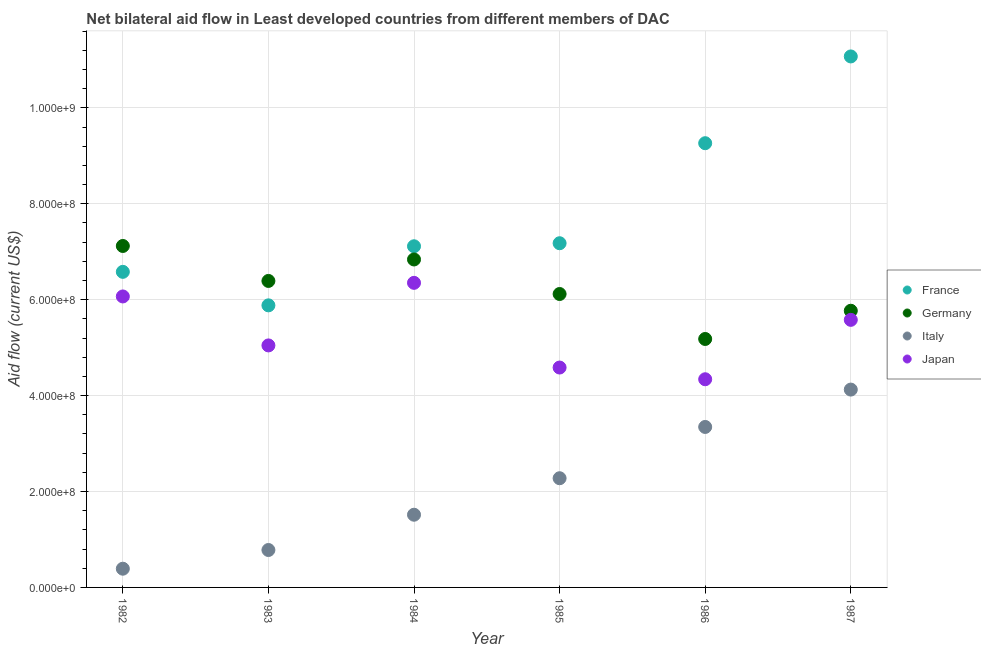What is the amount of aid given by italy in 1983?
Your response must be concise. 7.80e+07. Across all years, what is the maximum amount of aid given by japan?
Offer a very short reply. 6.35e+08. Across all years, what is the minimum amount of aid given by france?
Offer a very short reply. 5.88e+08. In which year was the amount of aid given by france minimum?
Provide a succinct answer. 1983. What is the total amount of aid given by germany in the graph?
Your response must be concise. 3.74e+09. What is the difference between the amount of aid given by germany in 1984 and that in 1985?
Make the answer very short. 7.20e+07. What is the difference between the amount of aid given by france in 1985 and the amount of aid given by italy in 1984?
Your answer should be compact. 5.66e+08. What is the average amount of aid given by france per year?
Ensure brevity in your answer.  7.85e+08. In the year 1982, what is the difference between the amount of aid given by japan and amount of aid given by germany?
Give a very brief answer. -1.05e+08. In how many years, is the amount of aid given by france greater than 1080000000 US$?
Provide a succinct answer. 1. What is the ratio of the amount of aid given by france in 1984 to that in 1985?
Keep it short and to the point. 0.99. Is the amount of aid given by japan in 1982 less than that in 1983?
Make the answer very short. No. What is the difference between the highest and the second highest amount of aid given by italy?
Provide a short and direct response. 7.79e+07. What is the difference between the highest and the lowest amount of aid given by japan?
Provide a succinct answer. 2.01e+08. Is the sum of the amount of aid given by germany in 1986 and 1987 greater than the maximum amount of aid given by italy across all years?
Provide a succinct answer. Yes. Is the amount of aid given by france strictly greater than the amount of aid given by germany over the years?
Offer a very short reply. No. How many dotlines are there?
Offer a very short reply. 4. How many years are there in the graph?
Your answer should be very brief. 6. What is the difference between two consecutive major ticks on the Y-axis?
Provide a short and direct response. 2.00e+08. Are the values on the major ticks of Y-axis written in scientific E-notation?
Provide a short and direct response. Yes. Does the graph contain any zero values?
Offer a very short reply. No. Does the graph contain grids?
Your answer should be compact. Yes. How many legend labels are there?
Your answer should be compact. 4. What is the title of the graph?
Make the answer very short. Net bilateral aid flow in Least developed countries from different members of DAC. Does "WFP" appear as one of the legend labels in the graph?
Offer a very short reply. No. What is the label or title of the Y-axis?
Your answer should be very brief. Aid flow (current US$). What is the Aid flow (current US$) in France in 1982?
Make the answer very short. 6.58e+08. What is the Aid flow (current US$) of Germany in 1982?
Provide a short and direct response. 7.12e+08. What is the Aid flow (current US$) in Italy in 1982?
Your answer should be compact. 3.90e+07. What is the Aid flow (current US$) in Japan in 1982?
Keep it short and to the point. 6.07e+08. What is the Aid flow (current US$) of France in 1983?
Your answer should be very brief. 5.88e+08. What is the Aid flow (current US$) in Germany in 1983?
Your answer should be compact. 6.39e+08. What is the Aid flow (current US$) of Italy in 1983?
Provide a succinct answer. 7.80e+07. What is the Aid flow (current US$) in Japan in 1983?
Provide a short and direct response. 5.05e+08. What is the Aid flow (current US$) of France in 1984?
Your answer should be very brief. 7.11e+08. What is the Aid flow (current US$) of Germany in 1984?
Offer a terse response. 6.84e+08. What is the Aid flow (current US$) of Italy in 1984?
Your answer should be very brief. 1.52e+08. What is the Aid flow (current US$) in Japan in 1984?
Your answer should be compact. 6.35e+08. What is the Aid flow (current US$) of France in 1985?
Offer a very short reply. 7.18e+08. What is the Aid flow (current US$) of Germany in 1985?
Give a very brief answer. 6.12e+08. What is the Aid flow (current US$) in Italy in 1985?
Give a very brief answer. 2.28e+08. What is the Aid flow (current US$) of Japan in 1985?
Keep it short and to the point. 4.58e+08. What is the Aid flow (current US$) in France in 1986?
Make the answer very short. 9.26e+08. What is the Aid flow (current US$) in Germany in 1986?
Make the answer very short. 5.18e+08. What is the Aid flow (current US$) of Italy in 1986?
Give a very brief answer. 3.35e+08. What is the Aid flow (current US$) in Japan in 1986?
Your response must be concise. 4.34e+08. What is the Aid flow (current US$) in France in 1987?
Your response must be concise. 1.11e+09. What is the Aid flow (current US$) in Germany in 1987?
Make the answer very short. 5.77e+08. What is the Aid flow (current US$) in Italy in 1987?
Make the answer very short. 4.13e+08. What is the Aid flow (current US$) of Japan in 1987?
Provide a succinct answer. 5.58e+08. Across all years, what is the maximum Aid flow (current US$) of France?
Your response must be concise. 1.11e+09. Across all years, what is the maximum Aid flow (current US$) of Germany?
Your response must be concise. 7.12e+08. Across all years, what is the maximum Aid flow (current US$) of Italy?
Keep it short and to the point. 4.13e+08. Across all years, what is the maximum Aid flow (current US$) of Japan?
Provide a short and direct response. 6.35e+08. Across all years, what is the minimum Aid flow (current US$) in France?
Offer a very short reply. 5.88e+08. Across all years, what is the minimum Aid flow (current US$) in Germany?
Your response must be concise. 5.18e+08. Across all years, what is the minimum Aid flow (current US$) in Italy?
Your response must be concise. 3.90e+07. Across all years, what is the minimum Aid flow (current US$) in Japan?
Your answer should be very brief. 4.34e+08. What is the total Aid flow (current US$) of France in the graph?
Offer a terse response. 4.71e+09. What is the total Aid flow (current US$) in Germany in the graph?
Your answer should be compact. 3.74e+09. What is the total Aid flow (current US$) of Italy in the graph?
Give a very brief answer. 1.24e+09. What is the total Aid flow (current US$) in Japan in the graph?
Keep it short and to the point. 3.20e+09. What is the difference between the Aid flow (current US$) in France in 1982 and that in 1983?
Ensure brevity in your answer.  6.98e+07. What is the difference between the Aid flow (current US$) of Germany in 1982 and that in 1983?
Make the answer very short. 7.29e+07. What is the difference between the Aid flow (current US$) of Italy in 1982 and that in 1983?
Your response must be concise. -3.90e+07. What is the difference between the Aid flow (current US$) in Japan in 1982 and that in 1983?
Make the answer very short. 1.02e+08. What is the difference between the Aid flow (current US$) of France in 1982 and that in 1984?
Provide a short and direct response. -5.33e+07. What is the difference between the Aid flow (current US$) in Germany in 1982 and that in 1984?
Ensure brevity in your answer.  2.81e+07. What is the difference between the Aid flow (current US$) in Italy in 1982 and that in 1984?
Keep it short and to the point. -1.13e+08. What is the difference between the Aid flow (current US$) of Japan in 1982 and that in 1984?
Provide a succinct answer. -2.84e+07. What is the difference between the Aid flow (current US$) of France in 1982 and that in 1985?
Offer a very short reply. -5.97e+07. What is the difference between the Aid flow (current US$) in Germany in 1982 and that in 1985?
Keep it short and to the point. 1.00e+08. What is the difference between the Aid flow (current US$) of Italy in 1982 and that in 1985?
Your answer should be compact. -1.89e+08. What is the difference between the Aid flow (current US$) in Japan in 1982 and that in 1985?
Ensure brevity in your answer.  1.48e+08. What is the difference between the Aid flow (current US$) of France in 1982 and that in 1986?
Provide a short and direct response. -2.68e+08. What is the difference between the Aid flow (current US$) of Germany in 1982 and that in 1986?
Your answer should be very brief. 1.94e+08. What is the difference between the Aid flow (current US$) of Italy in 1982 and that in 1986?
Offer a very short reply. -2.96e+08. What is the difference between the Aid flow (current US$) of Japan in 1982 and that in 1986?
Provide a short and direct response. 1.73e+08. What is the difference between the Aid flow (current US$) in France in 1982 and that in 1987?
Provide a short and direct response. -4.49e+08. What is the difference between the Aid flow (current US$) in Germany in 1982 and that in 1987?
Provide a short and direct response. 1.35e+08. What is the difference between the Aid flow (current US$) in Italy in 1982 and that in 1987?
Your answer should be very brief. -3.74e+08. What is the difference between the Aid flow (current US$) of Japan in 1982 and that in 1987?
Make the answer very short. 4.88e+07. What is the difference between the Aid flow (current US$) of France in 1983 and that in 1984?
Provide a short and direct response. -1.23e+08. What is the difference between the Aid flow (current US$) in Germany in 1983 and that in 1984?
Keep it short and to the point. -4.48e+07. What is the difference between the Aid flow (current US$) of Italy in 1983 and that in 1984?
Offer a terse response. -7.36e+07. What is the difference between the Aid flow (current US$) in Japan in 1983 and that in 1984?
Provide a succinct answer. -1.30e+08. What is the difference between the Aid flow (current US$) of France in 1983 and that in 1985?
Make the answer very short. -1.30e+08. What is the difference between the Aid flow (current US$) of Germany in 1983 and that in 1985?
Your answer should be very brief. 2.72e+07. What is the difference between the Aid flow (current US$) of Italy in 1983 and that in 1985?
Provide a succinct answer. -1.50e+08. What is the difference between the Aid flow (current US$) in Japan in 1983 and that in 1985?
Make the answer very short. 4.61e+07. What is the difference between the Aid flow (current US$) of France in 1983 and that in 1986?
Give a very brief answer. -3.38e+08. What is the difference between the Aid flow (current US$) of Germany in 1983 and that in 1986?
Your answer should be very brief. 1.21e+08. What is the difference between the Aid flow (current US$) in Italy in 1983 and that in 1986?
Give a very brief answer. -2.57e+08. What is the difference between the Aid flow (current US$) of Japan in 1983 and that in 1986?
Offer a terse response. 7.06e+07. What is the difference between the Aid flow (current US$) of France in 1983 and that in 1987?
Your response must be concise. -5.19e+08. What is the difference between the Aid flow (current US$) in Germany in 1983 and that in 1987?
Make the answer very short. 6.22e+07. What is the difference between the Aid flow (current US$) in Italy in 1983 and that in 1987?
Your answer should be very brief. -3.35e+08. What is the difference between the Aid flow (current US$) in Japan in 1983 and that in 1987?
Make the answer very short. -5.33e+07. What is the difference between the Aid flow (current US$) in France in 1984 and that in 1985?
Make the answer very short. -6.33e+06. What is the difference between the Aid flow (current US$) in Germany in 1984 and that in 1985?
Offer a terse response. 7.20e+07. What is the difference between the Aid flow (current US$) in Italy in 1984 and that in 1985?
Offer a terse response. -7.61e+07. What is the difference between the Aid flow (current US$) of Japan in 1984 and that in 1985?
Ensure brevity in your answer.  1.77e+08. What is the difference between the Aid flow (current US$) of France in 1984 and that in 1986?
Keep it short and to the point. -2.15e+08. What is the difference between the Aid flow (current US$) of Germany in 1984 and that in 1986?
Your response must be concise. 1.66e+08. What is the difference between the Aid flow (current US$) in Italy in 1984 and that in 1986?
Offer a very short reply. -1.83e+08. What is the difference between the Aid flow (current US$) of Japan in 1984 and that in 1986?
Ensure brevity in your answer.  2.01e+08. What is the difference between the Aid flow (current US$) of France in 1984 and that in 1987?
Provide a succinct answer. -3.96e+08. What is the difference between the Aid flow (current US$) of Germany in 1984 and that in 1987?
Make the answer very short. 1.07e+08. What is the difference between the Aid flow (current US$) of Italy in 1984 and that in 1987?
Your answer should be very brief. -2.61e+08. What is the difference between the Aid flow (current US$) in Japan in 1984 and that in 1987?
Make the answer very short. 7.72e+07. What is the difference between the Aid flow (current US$) in France in 1985 and that in 1986?
Offer a terse response. -2.09e+08. What is the difference between the Aid flow (current US$) in Germany in 1985 and that in 1986?
Provide a short and direct response. 9.38e+07. What is the difference between the Aid flow (current US$) in Italy in 1985 and that in 1986?
Provide a short and direct response. -1.07e+08. What is the difference between the Aid flow (current US$) in Japan in 1985 and that in 1986?
Give a very brief answer. 2.44e+07. What is the difference between the Aid flow (current US$) of France in 1985 and that in 1987?
Ensure brevity in your answer.  -3.89e+08. What is the difference between the Aid flow (current US$) of Germany in 1985 and that in 1987?
Give a very brief answer. 3.49e+07. What is the difference between the Aid flow (current US$) in Italy in 1985 and that in 1987?
Your answer should be compact. -1.85e+08. What is the difference between the Aid flow (current US$) in Japan in 1985 and that in 1987?
Offer a terse response. -9.94e+07. What is the difference between the Aid flow (current US$) in France in 1986 and that in 1987?
Provide a succinct answer. -1.81e+08. What is the difference between the Aid flow (current US$) of Germany in 1986 and that in 1987?
Your answer should be compact. -5.89e+07. What is the difference between the Aid flow (current US$) of Italy in 1986 and that in 1987?
Provide a succinct answer. -7.79e+07. What is the difference between the Aid flow (current US$) in Japan in 1986 and that in 1987?
Keep it short and to the point. -1.24e+08. What is the difference between the Aid flow (current US$) in France in 1982 and the Aid flow (current US$) in Germany in 1983?
Offer a very short reply. 1.90e+07. What is the difference between the Aid flow (current US$) in France in 1982 and the Aid flow (current US$) in Italy in 1983?
Make the answer very short. 5.80e+08. What is the difference between the Aid flow (current US$) of France in 1982 and the Aid flow (current US$) of Japan in 1983?
Your answer should be compact. 1.53e+08. What is the difference between the Aid flow (current US$) in Germany in 1982 and the Aid flow (current US$) in Italy in 1983?
Offer a terse response. 6.34e+08. What is the difference between the Aid flow (current US$) of Germany in 1982 and the Aid flow (current US$) of Japan in 1983?
Your answer should be compact. 2.07e+08. What is the difference between the Aid flow (current US$) in Italy in 1982 and the Aid flow (current US$) in Japan in 1983?
Ensure brevity in your answer.  -4.66e+08. What is the difference between the Aid flow (current US$) of France in 1982 and the Aid flow (current US$) of Germany in 1984?
Make the answer very short. -2.58e+07. What is the difference between the Aid flow (current US$) in France in 1982 and the Aid flow (current US$) in Italy in 1984?
Provide a succinct answer. 5.06e+08. What is the difference between the Aid flow (current US$) in France in 1982 and the Aid flow (current US$) in Japan in 1984?
Your response must be concise. 2.29e+07. What is the difference between the Aid flow (current US$) of Germany in 1982 and the Aid flow (current US$) of Italy in 1984?
Provide a succinct answer. 5.60e+08. What is the difference between the Aid flow (current US$) of Germany in 1982 and the Aid flow (current US$) of Japan in 1984?
Your answer should be compact. 7.69e+07. What is the difference between the Aid flow (current US$) in Italy in 1982 and the Aid flow (current US$) in Japan in 1984?
Your answer should be compact. -5.96e+08. What is the difference between the Aid flow (current US$) in France in 1982 and the Aid flow (current US$) in Germany in 1985?
Offer a very short reply. 4.62e+07. What is the difference between the Aid flow (current US$) of France in 1982 and the Aid flow (current US$) of Italy in 1985?
Your answer should be compact. 4.30e+08. What is the difference between the Aid flow (current US$) in France in 1982 and the Aid flow (current US$) in Japan in 1985?
Provide a short and direct response. 2.00e+08. What is the difference between the Aid flow (current US$) of Germany in 1982 and the Aid flow (current US$) of Italy in 1985?
Your response must be concise. 4.84e+08. What is the difference between the Aid flow (current US$) of Germany in 1982 and the Aid flow (current US$) of Japan in 1985?
Make the answer very short. 2.53e+08. What is the difference between the Aid flow (current US$) in Italy in 1982 and the Aid flow (current US$) in Japan in 1985?
Provide a succinct answer. -4.19e+08. What is the difference between the Aid flow (current US$) in France in 1982 and the Aid flow (current US$) in Germany in 1986?
Make the answer very short. 1.40e+08. What is the difference between the Aid flow (current US$) of France in 1982 and the Aid flow (current US$) of Italy in 1986?
Your response must be concise. 3.23e+08. What is the difference between the Aid flow (current US$) in France in 1982 and the Aid flow (current US$) in Japan in 1986?
Ensure brevity in your answer.  2.24e+08. What is the difference between the Aid flow (current US$) in Germany in 1982 and the Aid flow (current US$) in Italy in 1986?
Your answer should be very brief. 3.77e+08. What is the difference between the Aid flow (current US$) in Germany in 1982 and the Aid flow (current US$) in Japan in 1986?
Offer a very short reply. 2.78e+08. What is the difference between the Aid flow (current US$) in Italy in 1982 and the Aid flow (current US$) in Japan in 1986?
Your answer should be compact. -3.95e+08. What is the difference between the Aid flow (current US$) of France in 1982 and the Aid flow (current US$) of Germany in 1987?
Give a very brief answer. 8.11e+07. What is the difference between the Aid flow (current US$) of France in 1982 and the Aid flow (current US$) of Italy in 1987?
Offer a terse response. 2.45e+08. What is the difference between the Aid flow (current US$) in France in 1982 and the Aid flow (current US$) in Japan in 1987?
Provide a succinct answer. 1.00e+08. What is the difference between the Aid flow (current US$) in Germany in 1982 and the Aid flow (current US$) in Italy in 1987?
Ensure brevity in your answer.  2.99e+08. What is the difference between the Aid flow (current US$) in Germany in 1982 and the Aid flow (current US$) in Japan in 1987?
Provide a succinct answer. 1.54e+08. What is the difference between the Aid flow (current US$) of Italy in 1982 and the Aid flow (current US$) of Japan in 1987?
Keep it short and to the point. -5.19e+08. What is the difference between the Aid flow (current US$) of France in 1983 and the Aid flow (current US$) of Germany in 1984?
Provide a short and direct response. -9.57e+07. What is the difference between the Aid flow (current US$) of France in 1983 and the Aid flow (current US$) of Italy in 1984?
Your answer should be compact. 4.37e+08. What is the difference between the Aid flow (current US$) of France in 1983 and the Aid flow (current US$) of Japan in 1984?
Your response must be concise. -4.69e+07. What is the difference between the Aid flow (current US$) in Germany in 1983 and the Aid flow (current US$) in Italy in 1984?
Make the answer very short. 4.87e+08. What is the difference between the Aid flow (current US$) in Germany in 1983 and the Aid flow (current US$) in Japan in 1984?
Make the answer very short. 3.96e+06. What is the difference between the Aid flow (current US$) in Italy in 1983 and the Aid flow (current US$) in Japan in 1984?
Your response must be concise. -5.57e+08. What is the difference between the Aid flow (current US$) of France in 1983 and the Aid flow (current US$) of Germany in 1985?
Your answer should be very brief. -2.36e+07. What is the difference between the Aid flow (current US$) in France in 1983 and the Aid flow (current US$) in Italy in 1985?
Provide a succinct answer. 3.60e+08. What is the difference between the Aid flow (current US$) in France in 1983 and the Aid flow (current US$) in Japan in 1985?
Give a very brief answer. 1.30e+08. What is the difference between the Aid flow (current US$) of Germany in 1983 and the Aid flow (current US$) of Italy in 1985?
Make the answer very short. 4.11e+08. What is the difference between the Aid flow (current US$) in Germany in 1983 and the Aid flow (current US$) in Japan in 1985?
Give a very brief answer. 1.81e+08. What is the difference between the Aid flow (current US$) in Italy in 1983 and the Aid flow (current US$) in Japan in 1985?
Ensure brevity in your answer.  -3.80e+08. What is the difference between the Aid flow (current US$) in France in 1983 and the Aid flow (current US$) in Germany in 1986?
Provide a succinct answer. 7.01e+07. What is the difference between the Aid flow (current US$) of France in 1983 and the Aid flow (current US$) of Italy in 1986?
Give a very brief answer. 2.54e+08. What is the difference between the Aid flow (current US$) in France in 1983 and the Aid flow (current US$) in Japan in 1986?
Provide a short and direct response. 1.54e+08. What is the difference between the Aid flow (current US$) of Germany in 1983 and the Aid flow (current US$) of Italy in 1986?
Offer a terse response. 3.04e+08. What is the difference between the Aid flow (current US$) in Germany in 1983 and the Aid flow (current US$) in Japan in 1986?
Your answer should be compact. 2.05e+08. What is the difference between the Aid flow (current US$) of Italy in 1983 and the Aid flow (current US$) of Japan in 1986?
Provide a succinct answer. -3.56e+08. What is the difference between the Aid flow (current US$) in France in 1983 and the Aid flow (current US$) in Germany in 1987?
Ensure brevity in your answer.  1.13e+07. What is the difference between the Aid flow (current US$) in France in 1983 and the Aid flow (current US$) in Italy in 1987?
Keep it short and to the point. 1.76e+08. What is the difference between the Aid flow (current US$) of France in 1983 and the Aid flow (current US$) of Japan in 1987?
Make the answer very short. 3.02e+07. What is the difference between the Aid flow (current US$) of Germany in 1983 and the Aid flow (current US$) of Italy in 1987?
Keep it short and to the point. 2.27e+08. What is the difference between the Aid flow (current US$) of Germany in 1983 and the Aid flow (current US$) of Japan in 1987?
Your response must be concise. 8.11e+07. What is the difference between the Aid flow (current US$) in Italy in 1983 and the Aid flow (current US$) in Japan in 1987?
Keep it short and to the point. -4.80e+08. What is the difference between the Aid flow (current US$) in France in 1984 and the Aid flow (current US$) in Germany in 1985?
Give a very brief answer. 9.95e+07. What is the difference between the Aid flow (current US$) in France in 1984 and the Aid flow (current US$) in Italy in 1985?
Provide a short and direct response. 4.84e+08. What is the difference between the Aid flow (current US$) in France in 1984 and the Aid flow (current US$) in Japan in 1985?
Keep it short and to the point. 2.53e+08. What is the difference between the Aid flow (current US$) in Germany in 1984 and the Aid flow (current US$) in Italy in 1985?
Your response must be concise. 4.56e+08. What is the difference between the Aid flow (current US$) in Germany in 1984 and the Aid flow (current US$) in Japan in 1985?
Offer a terse response. 2.25e+08. What is the difference between the Aid flow (current US$) in Italy in 1984 and the Aid flow (current US$) in Japan in 1985?
Offer a very short reply. -3.07e+08. What is the difference between the Aid flow (current US$) of France in 1984 and the Aid flow (current US$) of Germany in 1986?
Provide a succinct answer. 1.93e+08. What is the difference between the Aid flow (current US$) in France in 1984 and the Aid flow (current US$) in Italy in 1986?
Your response must be concise. 3.77e+08. What is the difference between the Aid flow (current US$) of France in 1984 and the Aid flow (current US$) of Japan in 1986?
Offer a terse response. 2.77e+08. What is the difference between the Aid flow (current US$) in Germany in 1984 and the Aid flow (current US$) in Italy in 1986?
Your answer should be very brief. 3.49e+08. What is the difference between the Aid flow (current US$) of Germany in 1984 and the Aid flow (current US$) of Japan in 1986?
Give a very brief answer. 2.50e+08. What is the difference between the Aid flow (current US$) of Italy in 1984 and the Aid flow (current US$) of Japan in 1986?
Your response must be concise. -2.82e+08. What is the difference between the Aid flow (current US$) in France in 1984 and the Aid flow (current US$) in Germany in 1987?
Ensure brevity in your answer.  1.34e+08. What is the difference between the Aid flow (current US$) in France in 1984 and the Aid flow (current US$) in Italy in 1987?
Provide a succinct answer. 2.99e+08. What is the difference between the Aid flow (current US$) of France in 1984 and the Aid flow (current US$) of Japan in 1987?
Your answer should be very brief. 1.53e+08. What is the difference between the Aid flow (current US$) in Germany in 1984 and the Aid flow (current US$) in Italy in 1987?
Offer a terse response. 2.71e+08. What is the difference between the Aid flow (current US$) of Germany in 1984 and the Aid flow (current US$) of Japan in 1987?
Ensure brevity in your answer.  1.26e+08. What is the difference between the Aid flow (current US$) of Italy in 1984 and the Aid flow (current US$) of Japan in 1987?
Your answer should be compact. -4.06e+08. What is the difference between the Aid flow (current US$) of France in 1985 and the Aid flow (current US$) of Germany in 1986?
Ensure brevity in your answer.  2.00e+08. What is the difference between the Aid flow (current US$) of France in 1985 and the Aid flow (current US$) of Italy in 1986?
Offer a very short reply. 3.83e+08. What is the difference between the Aid flow (current US$) in France in 1985 and the Aid flow (current US$) in Japan in 1986?
Give a very brief answer. 2.84e+08. What is the difference between the Aid flow (current US$) in Germany in 1985 and the Aid flow (current US$) in Italy in 1986?
Keep it short and to the point. 2.77e+08. What is the difference between the Aid flow (current US$) of Germany in 1985 and the Aid flow (current US$) of Japan in 1986?
Provide a short and direct response. 1.78e+08. What is the difference between the Aid flow (current US$) in Italy in 1985 and the Aid flow (current US$) in Japan in 1986?
Offer a terse response. -2.06e+08. What is the difference between the Aid flow (current US$) of France in 1985 and the Aid flow (current US$) of Germany in 1987?
Give a very brief answer. 1.41e+08. What is the difference between the Aid flow (current US$) in France in 1985 and the Aid flow (current US$) in Italy in 1987?
Give a very brief answer. 3.05e+08. What is the difference between the Aid flow (current US$) in France in 1985 and the Aid flow (current US$) in Japan in 1987?
Your response must be concise. 1.60e+08. What is the difference between the Aid flow (current US$) in Germany in 1985 and the Aid flow (current US$) in Italy in 1987?
Ensure brevity in your answer.  1.99e+08. What is the difference between the Aid flow (current US$) of Germany in 1985 and the Aid flow (current US$) of Japan in 1987?
Your response must be concise. 5.39e+07. What is the difference between the Aid flow (current US$) of Italy in 1985 and the Aid flow (current US$) of Japan in 1987?
Your answer should be very brief. -3.30e+08. What is the difference between the Aid flow (current US$) of France in 1986 and the Aid flow (current US$) of Germany in 1987?
Offer a terse response. 3.49e+08. What is the difference between the Aid flow (current US$) of France in 1986 and the Aid flow (current US$) of Italy in 1987?
Ensure brevity in your answer.  5.14e+08. What is the difference between the Aid flow (current US$) in France in 1986 and the Aid flow (current US$) in Japan in 1987?
Ensure brevity in your answer.  3.68e+08. What is the difference between the Aid flow (current US$) of Germany in 1986 and the Aid flow (current US$) of Italy in 1987?
Offer a terse response. 1.06e+08. What is the difference between the Aid flow (current US$) of Germany in 1986 and the Aid flow (current US$) of Japan in 1987?
Your response must be concise. -3.99e+07. What is the difference between the Aid flow (current US$) in Italy in 1986 and the Aid flow (current US$) in Japan in 1987?
Ensure brevity in your answer.  -2.23e+08. What is the average Aid flow (current US$) in France per year?
Make the answer very short. 7.85e+08. What is the average Aid flow (current US$) in Germany per year?
Offer a terse response. 6.24e+08. What is the average Aid flow (current US$) of Italy per year?
Give a very brief answer. 2.07e+08. What is the average Aid flow (current US$) in Japan per year?
Offer a terse response. 5.33e+08. In the year 1982, what is the difference between the Aid flow (current US$) of France and Aid flow (current US$) of Germany?
Give a very brief answer. -5.40e+07. In the year 1982, what is the difference between the Aid flow (current US$) of France and Aid flow (current US$) of Italy?
Your response must be concise. 6.19e+08. In the year 1982, what is the difference between the Aid flow (current US$) in France and Aid flow (current US$) in Japan?
Keep it short and to the point. 5.13e+07. In the year 1982, what is the difference between the Aid flow (current US$) in Germany and Aid flow (current US$) in Italy?
Keep it short and to the point. 6.73e+08. In the year 1982, what is the difference between the Aid flow (current US$) of Germany and Aid flow (current US$) of Japan?
Your answer should be compact. 1.05e+08. In the year 1982, what is the difference between the Aid flow (current US$) in Italy and Aid flow (current US$) in Japan?
Your answer should be compact. -5.68e+08. In the year 1983, what is the difference between the Aid flow (current US$) in France and Aid flow (current US$) in Germany?
Make the answer very short. -5.09e+07. In the year 1983, what is the difference between the Aid flow (current US$) in France and Aid flow (current US$) in Italy?
Offer a very short reply. 5.10e+08. In the year 1983, what is the difference between the Aid flow (current US$) of France and Aid flow (current US$) of Japan?
Your answer should be very brief. 8.36e+07. In the year 1983, what is the difference between the Aid flow (current US$) of Germany and Aid flow (current US$) of Italy?
Your answer should be very brief. 5.61e+08. In the year 1983, what is the difference between the Aid flow (current US$) in Germany and Aid flow (current US$) in Japan?
Provide a succinct answer. 1.34e+08. In the year 1983, what is the difference between the Aid flow (current US$) of Italy and Aid flow (current US$) of Japan?
Offer a terse response. -4.27e+08. In the year 1984, what is the difference between the Aid flow (current US$) of France and Aid flow (current US$) of Germany?
Your answer should be very brief. 2.75e+07. In the year 1984, what is the difference between the Aid flow (current US$) in France and Aid flow (current US$) in Italy?
Give a very brief answer. 5.60e+08. In the year 1984, what is the difference between the Aid flow (current US$) of France and Aid flow (current US$) of Japan?
Make the answer very short. 7.63e+07. In the year 1984, what is the difference between the Aid flow (current US$) of Germany and Aid flow (current US$) of Italy?
Your response must be concise. 5.32e+08. In the year 1984, what is the difference between the Aid flow (current US$) in Germany and Aid flow (current US$) in Japan?
Provide a short and direct response. 4.87e+07. In the year 1984, what is the difference between the Aid flow (current US$) of Italy and Aid flow (current US$) of Japan?
Give a very brief answer. -4.84e+08. In the year 1985, what is the difference between the Aid flow (current US$) of France and Aid flow (current US$) of Germany?
Offer a terse response. 1.06e+08. In the year 1985, what is the difference between the Aid flow (current US$) in France and Aid flow (current US$) in Italy?
Offer a very short reply. 4.90e+08. In the year 1985, what is the difference between the Aid flow (current US$) of France and Aid flow (current US$) of Japan?
Your answer should be very brief. 2.59e+08. In the year 1985, what is the difference between the Aid flow (current US$) of Germany and Aid flow (current US$) of Italy?
Give a very brief answer. 3.84e+08. In the year 1985, what is the difference between the Aid flow (current US$) of Germany and Aid flow (current US$) of Japan?
Offer a very short reply. 1.53e+08. In the year 1985, what is the difference between the Aid flow (current US$) in Italy and Aid flow (current US$) in Japan?
Your answer should be compact. -2.31e+08. In the year 1986, what is the difference between the Aid flow (current US$) in France and Aid flow (current US$) in Germany?
Offer a terse response. 4.08e+08. In the year 1986, what is the difference between the Aid flow (current US$) in France and Aid flow (current US$) in Italy?
Your answer should be very brief. 5.92e+08. In the year 1986, what is the difference between the Aid flow (current US$) in France and Aid flow (current US$) in Japan?
Your answer should be compact. 4.92e+08. In the year 1986, what is the difference between the Aid flow (current US$) of Germany and Aid flow (current US$) of Italy?
Your answer should be compact. 1.83e+08. In the year 1986, what is the difference between the Aid flow (current US$) of Germany and Aid flow (current US$) of Japan?
Give a very brief answer. 8.40e+07. In the year 1986, what is the difference between the Aid flow (current US$) in Italy and Aid flow (current US$) in Japan?
Your response must be concise. -9.95e+07. In the year 1987, what is the difference between the Aid flow (current US$) in France and Aid flow (current US$) in Germany?
Keep it short and to the point. 5.30e+08. In the year 1987, what is the difference between the Aid flow (current US$) in France and Aid flow (current US$) in Italy?
Make the answer very short. 6.95e+08. In the year 1987, what is the difference between the Aid flow (current US$) in France and Aid flow (current US$) in Japan?
Give a very brief answer. 5.49e+08. In the year 1987, what is the difference between the Aid flow (current US$) of Germany and Aid flow (current US$) of Italy?
Keep it short and to the point. 1.64e+08. In the year 1987, what is the difference between the Aid flow (current US$) in Germany and Aid flow (current US$) in Japan?
Give a very brief answer. 1.90e+07. In the year 1987, what is the difference between the Aid flow (current US$) of Italy and Aid flow (current US$) of Japan?
Offer a very short reply. -1.45e+08. What is the ratio of the Aid flow (current US$) of France in 1982 to that in 1983?
Keep it short and to the point. 1.12. What is the ratio of the Aid flow (current US$) in Germany in 1982 to that in 1983?
Offer a very short reply. 1.11. What is the ratio of the Aid flow (current US$) of Italy in 1982 to that in 1983?
Your answer should be very brief. 0.5. What is the ratio of the Aid flow (current US$) in Japan in 1982 to that in 1983?
Offer a very short reply. 1.2. What is the ratio of the Aid flow (current US$) of France in 1982 to that in 1984?
Provide a succinct answer. 0.93. What is the ratio of the Aid flow (current US$) of Germany in 1982 to that in 1984?
Give a very brief answer. 1.04. What is the ratio of the Aid flow (current US$) of Italy in 1982 to that in 1984?
Your answer should be very brief. 0.26. What is the ratio of the Aid flow (current US$) in Japan in 1982 to that in 1984?
Your answer should be very brief. 0.96. What is the ratio of the Aid flow (current US$) in France in 1982 to that in 1985?
Offer a terse response. 0.92. What is the ratio of the Aid flow (current US$) of Germany in 1982 to that in 1985?
Provide a succinct answer. 1.16. What is the ratio of the Aid flow (current US$) in Italy in 1982 to that in 1985?
Provide a succinct answer. 0.17. What is the ratio of the Aid flow (current US$) of Japan in 1982 to that in 1985?
Your answer should be compact. 1.32. What is the ratio of the Aid flow (current US$) in France in 1982 to that in 1986?
Offer a very short reply. 0.71. What is the ratio of the Aid flow (current US$) of Germany in 1982 to that in 1986?
Provide a short and direct response. 1.37. What is the ratio of the Aid flow (current US$) of Italy in 1982 to that in 1986?
Your response must be concise. 0.12. What is the ratio of the Aid flow (current US$) of Japan in 1982 to that in 1986?
Your answer should be very brief. 1.4. What is the ratio of the Aid flow (current US$) of France in 1982 to that in 1987?
Make the answer very short. 0.59. What is the ratio of the Aid flow (current US$) in Germany in 1982 to that in 1987?
Your response must be concise. 1.23. What is the ratio of the Aid flow (current US$) of Italy in 1982 to that in 1987?
Make the answer very short. 0.09. What is the ratio of the Aid flow (current US$) of Japan in 1982 to that in 1987?
Offer a very short reply. 1.09. What is the ratio of the Aid flow (current US$) of France in 1983 to that in 1984?
Your answer should be compact. 0.83. What is the ratio of the Aid flow (current US$) in Germany in 1983 to that in 1984?
Provide a short and direct response. 0.93. What is the ratio of the Aid flow (current US$) in Italy in 1983 to that in 1984?
Provide a succinct answer. 0.51. What is the ratio of the Aid flow (current US$) of Japan in 1983 to that in 1984?
Provide a succinct answer. 0.79. What is the ratio of the Aid flow (current US$) in France in 1983 to that in 1985?
Offer a terse response. 0.82. What is the ratio of the Aid flow (current US$) in Germany in 1983 to that in 1985?
Your response must be concise. 1.04. What is the ratio of the Aid flow (current US$) in Italy in 1983 to that in 1985?
Provide a short and direct response. 0.34. What is the ratio of the Aid flow (current US$) in Japan in 1983 to that in 1985?
Provide a short and direct response. 1.1. What is the ratio of the Aid flow (current US$) in France in 1983 to that in 1986?
Make the answer very short. 0.64. What is the ratio of the Aid flow (current US$) of Germany in 1983 to that in 1986?
Keep it short and to the point. 1.23. What is the ratio of the Aid flow (current US$) in Italy in 1983 to that in 1986?
Make the answer very short. 0.23. What is the ratio of the Aid flow (current US$) of Japan in 1983 to that in 1986?
Your answer should be compact. 1.16. What is the ratio of the Aid flow (current US$) in France in 1983 to that in 1987?
Your answer should be very brief. 0.53. What is the ratio of the Aid flow (current US$) in Germany in 1983 to that in 1987?
Provide a short and direct response. 1.11. What is the ratio of the Aid flow (current US$) in Italy in 1983 to that in 1987?
Your answer should be very brief. 0.19. What is the ratio of the Aid flow (current US$) of Japan in 1983 to that in 1987?
Give a very brief answer. 0.9. What is the ratio of the Aid flow (current US$) of France in 1984 to that in 1985?
Make the answer very short. 0.99. What is the ratio of the Aid flow (current US$) of Germany in 1984 to that in 1985?
Your response must be concise. 1.12. What is the ratio of the Aid flow (current US$) in Italy in 1984 to that in 1985?
Offer a very short reply. 0.67. What is the ratio of the Aid flow (current US$) in Japan in 1984 to that in 1985?
Offer a terse response. 1.39. What is the ratio of the Aid flow (current US$) of France in 1984 to that in 1986?
Make the answer very short. 0.77. What is the ratio of the Aid flow (current US$) in Germany in 1984 to that in 1986?
Provide a succinct answer. 1.32. What is the ratio of the Aid flow (current US$) of Italy in 1984 to that in 1986?
Keep it short and to the point. 0.45. What is the ratio of the Aid flow (current US$) in Japan in 1984 to that in 1986?
Make the answer very short. 1.46. What is the ratio of the Aid flow (current US$) in France in 1984 to that in 1987?
Provide a short and direct response. 0.64. What is the ratio of the Aid flow (current US$) of Germany in 1984 to that in 1987?
Ensure brevity in your answer.  1.19. What is the ratio of the Aid flow (current US$) of Italy in 1984 to that in 1987?
Offer a terse response. 0.37. What is the ratio of the Aid flow (current US$) of Japan in 1984 to that in 1987?
Your response must be concise. 1.14. What is the ratio of the Aid flow (current US$) of France in 1985 to that in 1986?
Provide a succinct answer. 0.77. What is the ratio of the Aid flow (current US$) in Germany in 1985 to that in 1986?
Offer a terse response. 1.18. What is the ratio of the Aid flow (current US$) in Italy in 1985 to that in 1986?
Make the answer very short. 0.68. What is the ratio of the Aid flow (current US$) in Japan in 1985 to that in 1986?
Offer a very short reply. 1.06. What is the ratio of the Aid flow (current US$) of France in 1985 to that in 1987?
Your answer should be compact. 0.65. What is the ratio of the Aid flow (current US$) of Germany in 1985 to that in 1987?
Ensure brevity in your answer.  1.06. What is the ratio of the Aid flow (current US$) in Italy in 1985 to that in 1987?
Ensure brevity in your answer.  0.55. What is the ratio of the Aid flow (current US$) of Japan in 1985 to that in 1987?
Keep it short and to the point. 0.82. What is the ratio of the Aid flow (current US$) in France in 1986 to that in 1987?
Your response must be concise. 0.84. What is the ratio of the Aid flow (current US$) of Germany in 1986 to that in 1987?
Give a very brief answer. 0.9. What is the ratio of the Aid flow (current US$) of Italy in 1986 to that in 1987?
Your answer should be compact. 0.81. What is the ratio of the Aid flow (current US$) of Japan in 1986 to that in 1987?
Offer a terse response. 0.78. What is the difference between the highest and the second highest Aid flow (current US$) of France?
Offer a terse response. 1.81e+08. What is the difference between the highest and the second highest Aid flow (current US$) of Germany?
Make the answer very short. 2.81e+07. What is the difference between the highest and the second highest Aid flow (current US$) in Italy?
Your answer should be compact. 7.79e+07. What is the difference between the highest and the second highest Aid flow (current US$) in Japan?
Your response must be concise. 2.84e+07. What is the difference between the highest and the lowest Aid flow (current US$) of France?
Offer a terse response. 5.19e+08. What is the difference between the highest and the lowest Aid flow (current US$) of Germany?
Your answer should be very brief. 1.94e+08. What is the difference between the highest and the lowest Aid flow (current US$) in Italy?
Provide a succinct answer. 3.74e+08. What is the difference between the highest and the lowest Aid flow (current US$) in Japan?
Provide a succinct answer. 2.01e+08. 